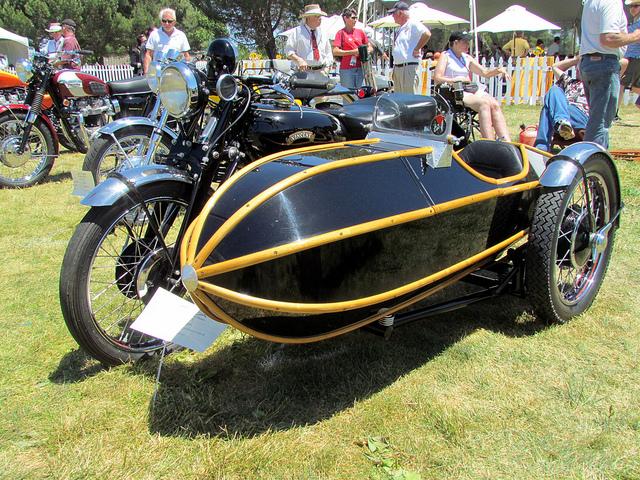What kind of event is this?
Short answer required. Car show. What vehicle is this?
Answer briefly. Motorcycle with sidecar. Is that a bomb?
Give a very brief answer. No. What brand is the sidecar?
Quick response, please. Harley. 